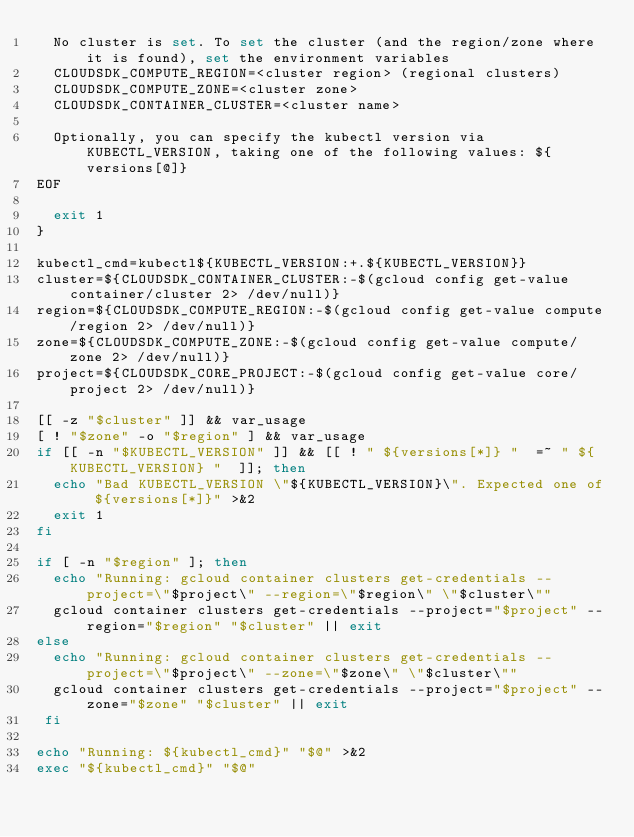Convert code to text. <code><loc_0><loc_0><loc_500><loc_500><_Bash_>  No cluster is set. To set the cluster (and the region/zone where it is found), set the environment variables
  CLOUDSDK_COMPUTE_REGION=<cluster region> (regional clusters)
  CLOUDSDK_COMPUTE_ZONE=<cluster zone>
  CLOUDSDK_CONTAINER_CLUSTER=<cluster name>

  Optionally, you can specify the kubectl version via KUBECTL_VERSION, taking one of the following values: ${versions[@]}
EOF

  exit 1
}

kubectl_cmd=kubectl${KUBECTL_VERSION:+.${KUBECTL_VERSION}}
cluster=${CLOUDSDK_CONTAINER_CLUSTER:-$(gcloud config get-value container/cluster 2> /dev/null)}
region=${CLOUDSDK_COMPUTE_REGION:-$(gcloud config get-value compute/region 2> /dev/null)}
zone=${CLOUDSDK_COMPUTE_ZONE:-$(gcloud config get-value compute/zone 2> /dev/null)}
project=${CLOUDSDK_CORE_PROJECT:-$(gcloud config get-value core/project 2> /dev/null)}

[[ -z "$cluster" ]] && var_usage
[ ! "$zone" -o "$region" ] && var_usage
if [[ -n "$KUBECTL_VERSION" ]] && [[ ! " ${versions[*]} "  =~ " ${KUBECTL_VERSION} "  ]]; then
  echo "Bad KUBECTL_VERSION \"${KUBECTL_VERSION}\". Expected one of ${versions[*]}" >&2
  exit 1
fi

if [ -n "$region" ]; then
  echo "Running: gcloud container clusters get-credentials --project=\"$project\" --region=\"$region\" \"$cluster\""
  gcloud container clusters get-credentials --project="$project" --region="$region" "$cluster" || exit
else
  echo "Running: gcloud container clusters get-credentials --project=\"$project\" --zone=\"$zone\" \"$cluster\""
  gcloud container clusters get-credentials --project="$project" --zone="$zone" "$cluster" || exit
 fi

echo "Running: ${kubectl_cmd}" "$@" >&2
exec "${kubectl_cmd}" "$@"
</code> 